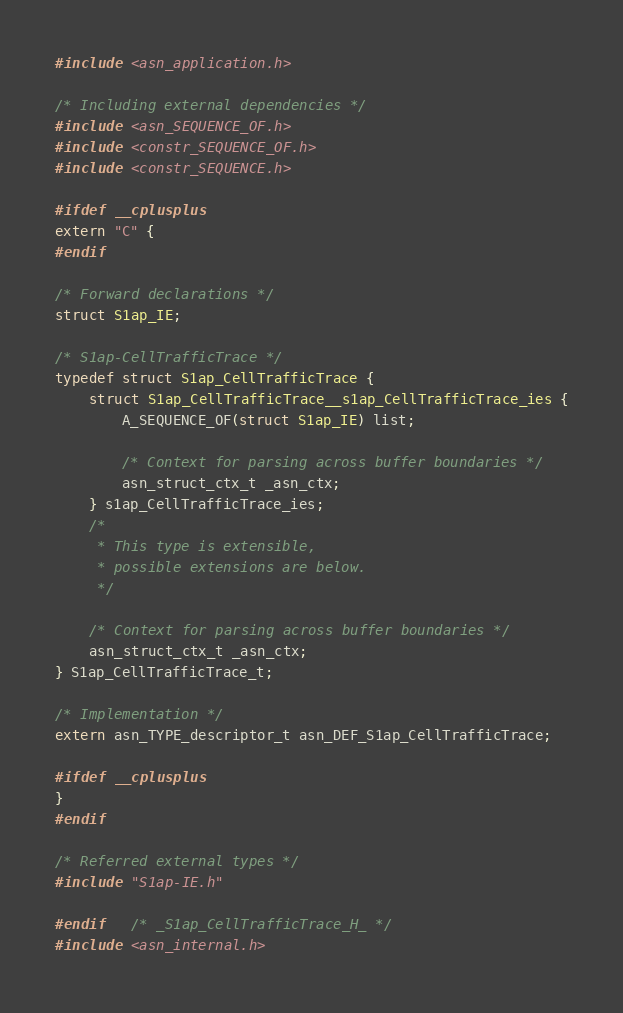Convert code to text. <code><loc_0><loc_0><loc_500><loc_500><_C_>
#include <asn_application.h>

/* Including external dependencies */
#include <asn_SEQUENCE_OF.h>
#include <constr_SEQUENCE_OF.h>
#include <constr_SEQUENCE.h>

#ifdef __cplusplus
extern "C" {
#endif

/* Forward declarations */
struct S1ap_IE;

/* S1ap-CellTrafficTrace */
typedef struct S1ap_CellTrafficTrace {
	struct S1ap_CellTrafficTrace__s1ap_CellTrafficTrace_ies {
		A_SEQUENCE_OF(struct S1ap_IE) list;
		
		/* Context for parsing across buffer boundaries */
		asn_struct_ctx_t _asn_ctx;
	} s1ap_CellTrafficTrace_ies;
	/*
	 * This type is extensible,
	 * possible extensions are below.
	 */
	
	/* Context for parsing across buffer boundaries */
	asn_struct_ctx_t _asn_ctx;
} S1ap_CellTrafficTrace_t;

/* Implementation */
extern asn_TYPE_descriptor_t asn_DEF_S1ap_CellTrafficTrace;

#ifdef __cplusplus
}
#endif

/* Referred external types */
#include "S1ap-IE.h"

#endif	/* _S1ap_CellTrafficTrace_H_ */
#include <asn_internal.h>
</code> 